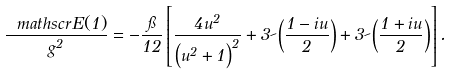Convert formula to latex. <formula><loc_0><loc_0><loc_500><loc_500>\frac { \ m a t h s c r { E } ( 1 ) } { g ^ { 2 } } = - \frac { \pi } { 1 2 } \left [ \frac { 4 u ^ { 2 } } { \left ( u ^ { 2 } + 1 \right ) ^ { 2 } } + 3 \psi \left ( \frac { 1 - i u } { 2 } \right ) + 3 \psi \left ( \frac { 1 + i u } { 2 } \right ) \right ] .</formula> 